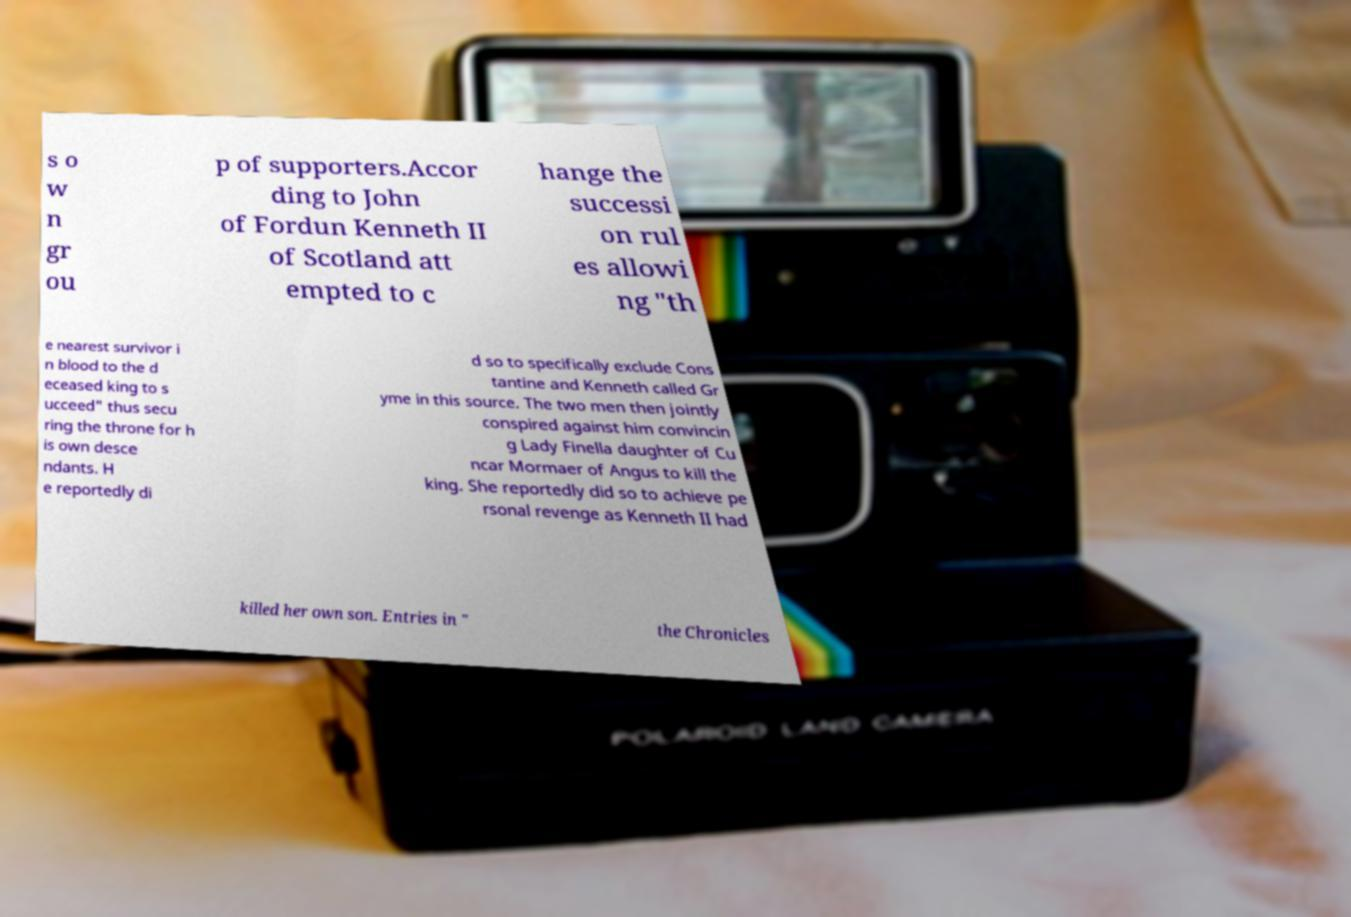Could you extract and type out the text from this image? s o w n gr ou p of supporters.Accor ding to John of Fordun Kenneth II of Scotland att empted to c hange the successi on rul es allowi ng "th e nearest survivor i n blood to the d eceased king to s ucceed" thus secu ring the throne for h is own desce ndants. H e reportedly di d so to specifically exclude Cons tantine and Kenneth called Gr yme in this source. The two men then jointly conspired against him convincin g Lady Finella daughter of Cu ncar Mormaer of Angus to kill the king. She reportedly did so to achieve pe rsonal revenge as Kenneth II had killed her own son. Entries in " the Chronicles 